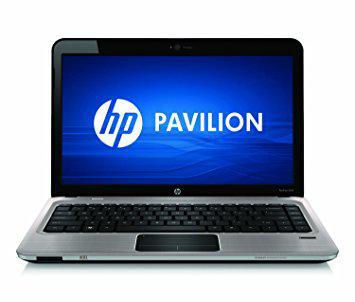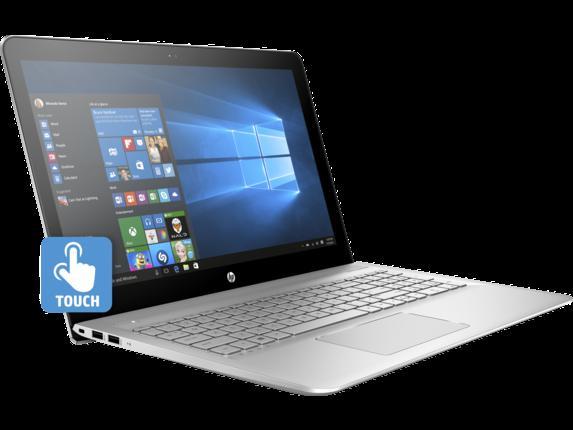The first image is the image on the left, the second image is the image on the right. Analyze the images presented: Is the assertion "Each open laptop is displayed head-on, and each screen contains a square with a black background on the left and glowing blue light that radiates leftward." valid? Answer yes or no. No. The first image is the image on the left, the second image is the image on the right. For the images shown, is this caption "Two laptop computers facing front are open with start screens showing, but with different colored keyboards." true? Answer yes or no. No. 